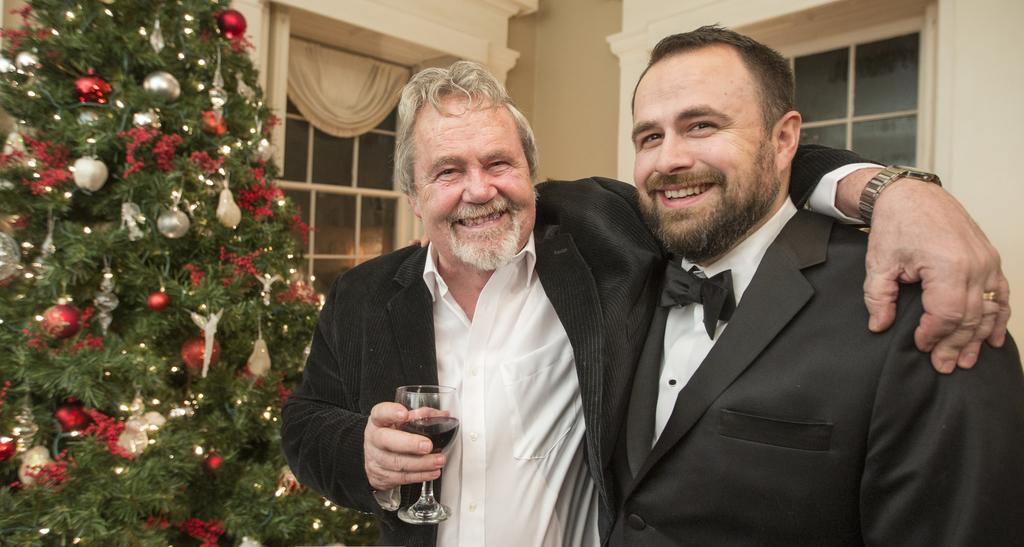What is the main object in the image? There is a Christmas tree in the image. How many people are in the image? There are two people in the image. What are the people doing in the image? The people are standing and holding glasses. What type of clover can be seen growing around the Christmas tree in the image? There is no clover present in the image; it is a Christmas tree with no plants around it. 